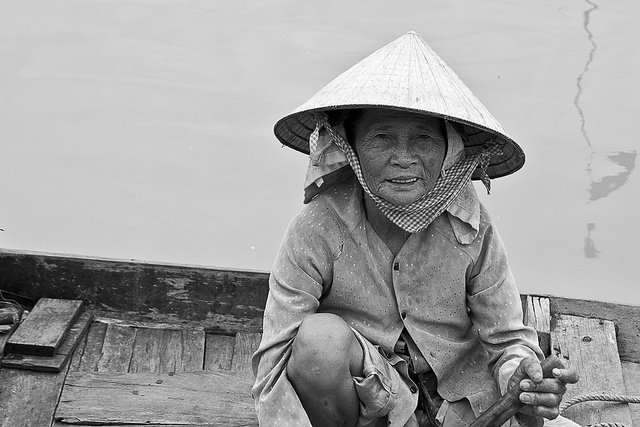Describe the objects in this image and their specific colors. I can see people in lightgray, gray, darkgray, and black tones and boat in lightgray, darkgray, gray, and black tones in this image. 